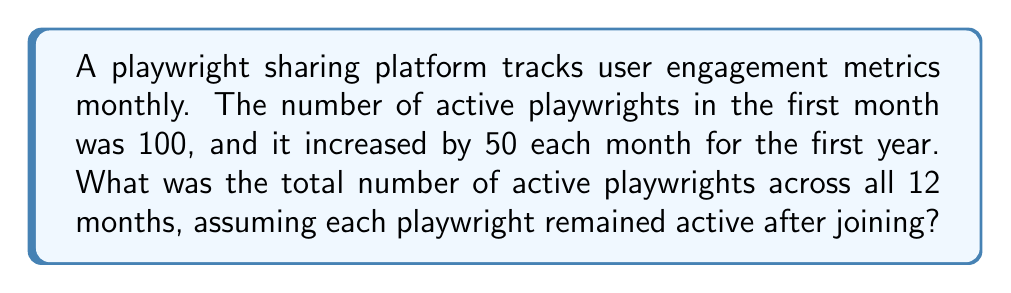What is the answer to this math problem? Let's approach this step-by-step using arithmetic progression:

1) We have an arithmetic sequence where:
   $a_1 = 100$ (first term)
   $d = 50$ (common difference)
   $n = 12$ (number of terms)

2) The number of active playwrights for each month forms the sequence:
   100, 150, 200, 250, ..., $a_{12}$

3) To find $a_{12}$ (the 12th term), we use the formula:
   $a_n = a_1 + (n-1)d$
   $a_{12} = 100 + (12-1)50 = 100 + 550 = 650$

4) Now, we need to find the sum of all terms. For arithmetic progression, we use:
   $S_n = \frac{n}{2}(a_1 + a_n)$
   Where $S_n$ is the sum of $n$ terms

5) Substituting our values:
   $S_{12} = \frac{12}{2}(100 + 650) = 6(750) = 4500$

6) However, this sum represents the number of active playwrights if we only counted new ones each month. We need to account for playwrights remaining active.

7) To do this, we calculate the cumulative sum:
   $\text{Total} = 100 + (100+150) + (100+150+200) + ... + (100+150+200+...+650)$

8) This is equivalent to:
   $\text{Total} = 12 \cdot 100 + 11 \cdot 50 + 10 \cdot 50 + ... + 1 \cdot 50$

9) Simplifying:
   $\text{Total} = 1200 + 50(11+10+9+...+1)$

10) The sum of numbers from 1 to 11 is $\frac{11 \cdot 12}{2} = 66$

11) Therefore:
    $\text{Total} = 1200 + 50 \cdot 66 = 1200 + 3300 = 4500$
Answer: 4500 